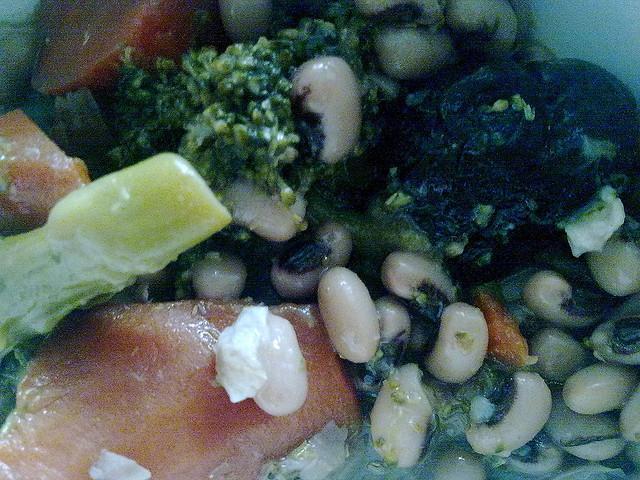How many artichokes are in the dish?
Give a very brief answer. 1. How many broccolis are in the picture?
Give a very brief answer. 4. How many bikes are there?
Give a very brief answer. 0. 